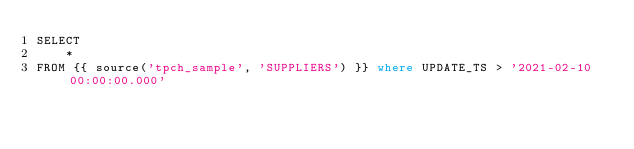<code> <loc_0><loc_0><loc_500><loc_500><_SQL_>SELECT
    *
FROM {{ source('tpch_sample', 'SUPPLIERS') }} where UPDATE_TS > '2021-02-10 00:00:00.000'</code> 